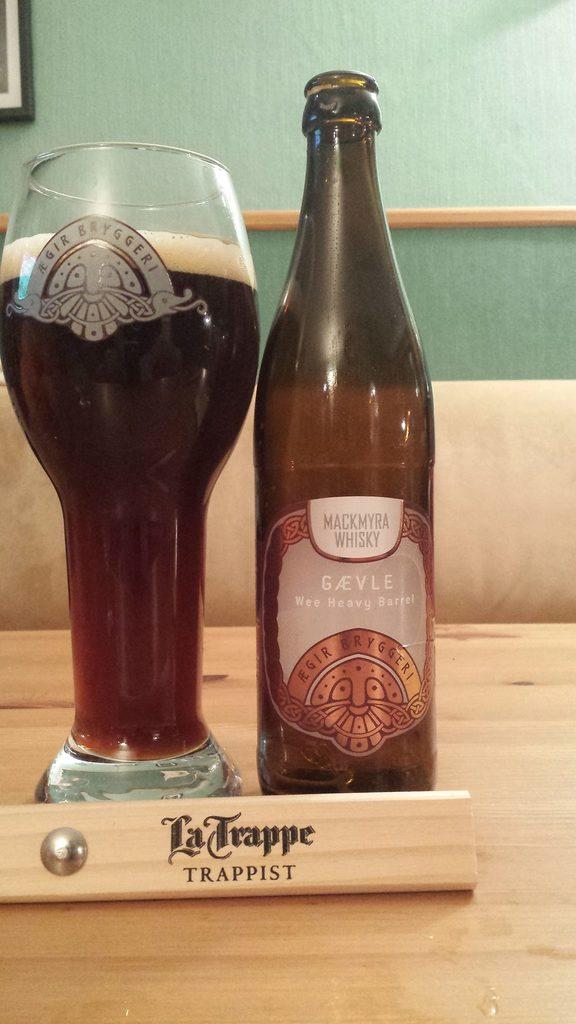<image>
Share a concise interpretation of the image provided. Wee Heavy Barrel beer bottle next to a large cup of beer. 